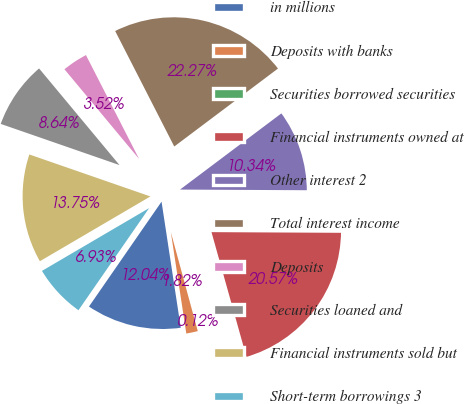<chart> <loc_0><loc_0><loc_500><loc_500><pie_chart><fcel>in millions<fcel>Deposits with banks<fcel>Securities borrowed securities<fcel>Financial instruments owned at<fcel>Other interest 2<fcel>Total interest income<fcel>Deposits<fcel>Securities loaned and<fcel>Financial instruments sold but<fcel>Short-term borrowings 3<nl><fcel>12.04%<fcel>1.82%<fcel>0.12%<fcel>20.57%<fcel>10.34%<fcel>22.27%<fcel>3.52%<fcel>8.64%<fcel>13.75%<fcel>6.93%<nl></chart> 